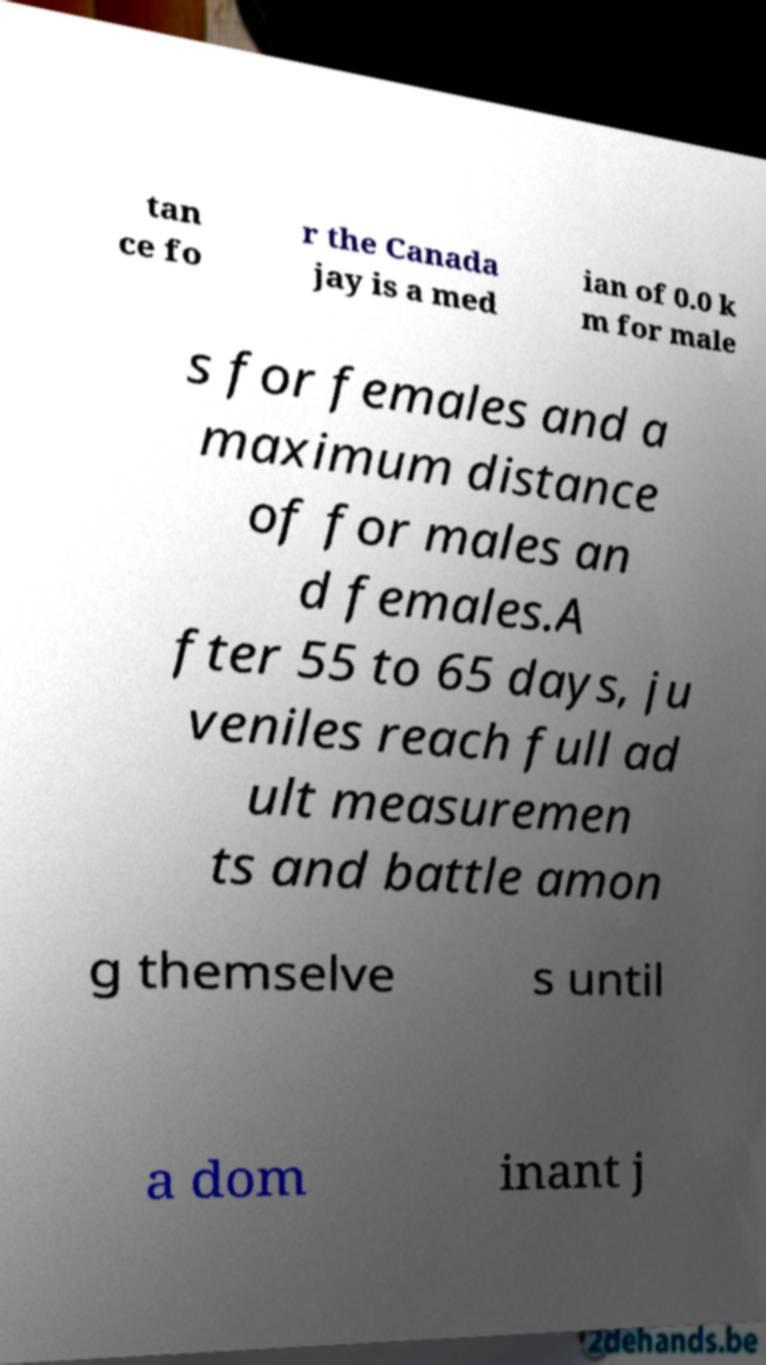Please identify and transcribe the text found in this image. tan ce fo r the Canada jay is a med ian of 0.0 k m for male s for females and a maximum distance of for males an d females.A fter 55 to 65 days, ju veniles reach full ad ult measuremen ts and battle amon g themselve s until a dom inant j 